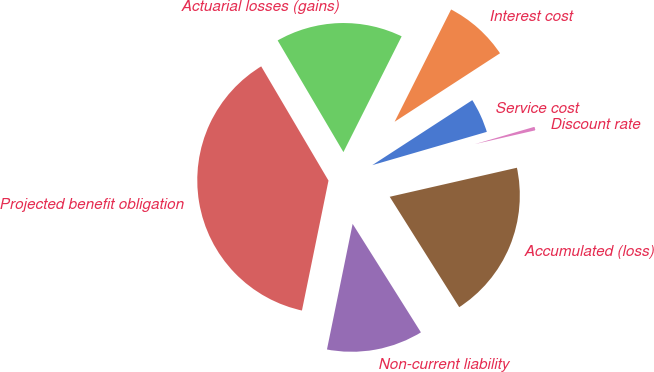<chart> <loc_0><loc_0><loc_500><loc_500><pie_chart><fcel>Service cost<fcel>Interest cost<fcel>Actuarial losses (gains)<fcel>Projected benefit obligation<fcel>Non-current liability<fcel>Accumulated (loss)<fcel>Discount rate<nl><fcel>4.67%<fcel>8.41%<fcel>15.89%<fcel>38.32%<fcel>12.15%<fcel>19.63%<fcel>0.93%<nl></chart> 